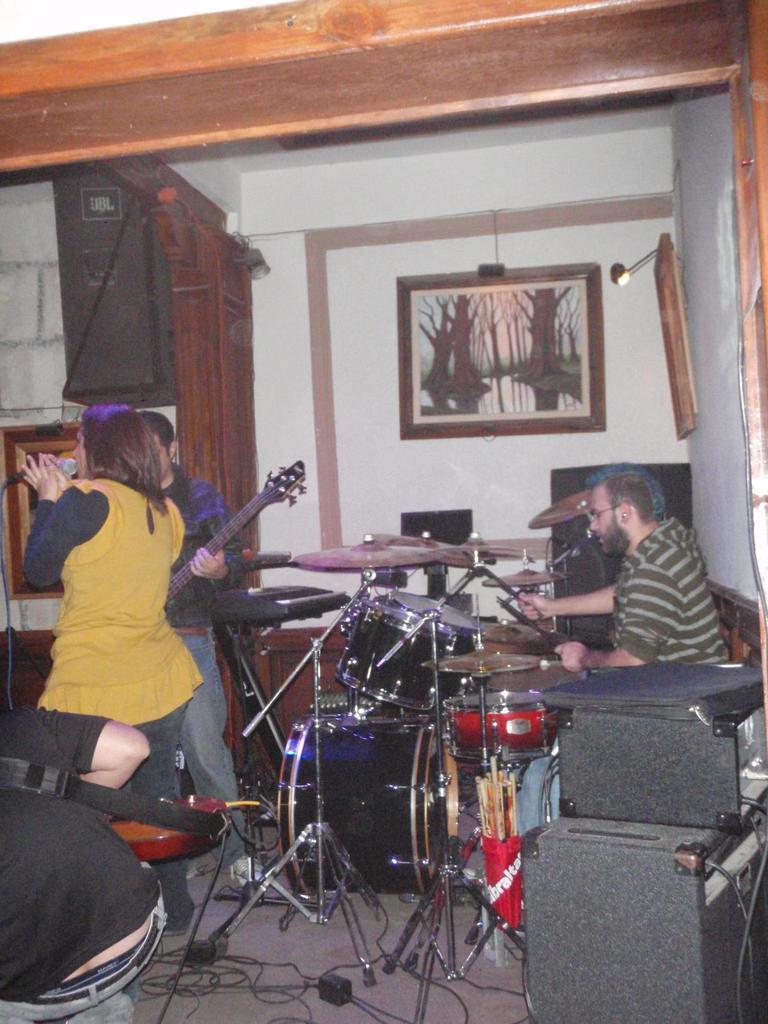How would you summarize this image in a sentence or two? In the image we can see four persons,three persons were standing and one person sitting. And we can see two persons were holding guitar. The woman she is holding microphone. And between them we can see some musical instruments. In front bottom we can see speaker,coming to background wall and photo frame. 